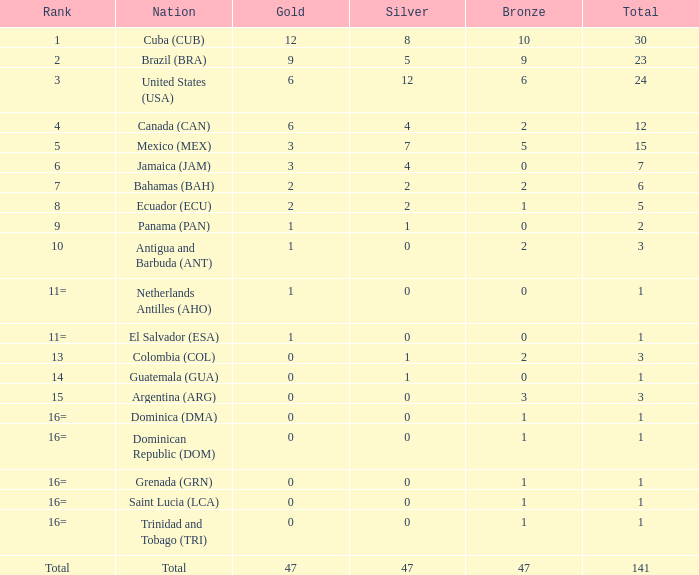What is the number of bronze medals held by jamaica (jam) with a total of less than 7? 0.0. 